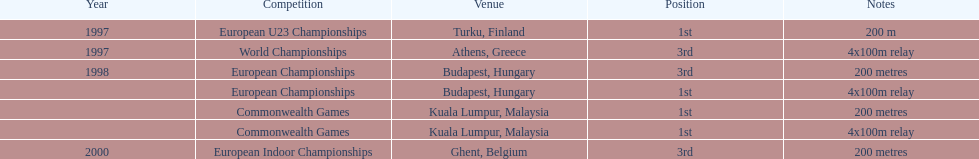In which year from 1997 to 2000 did julian golding, the uk and england sprinter, achieve first place in the 4 x 100 m relay and the 200 meters competition? 1998. 